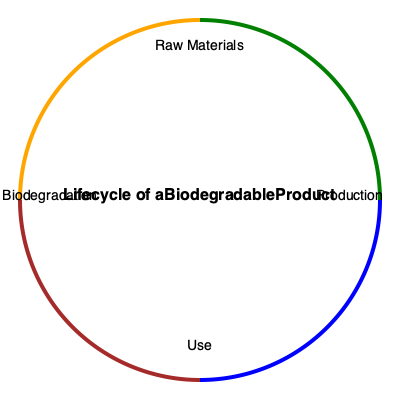In the lifecycle analysis of a biodegradable product, which stage typically has the highest carbon footprint, and what strategies can be implemented to reduce its environmental impact? To answer this question, let's analyze each stage of the lifecycle:

1. Raw Materials:
   - Generally has a lower carbon footprint compared to other stages
   - Involves extraction and processing of natural, renewable resources

2. Production:
   - Often has the highest carbon footprint due to:
     a) Energy-intensive manufacturing processes
     b) Use of machinery and equipment
     c) Transportation of materials to production facilities
   - Strategies to reduce impact:
     a) Implementing energy-efficient technologies
     b) Using renewable energy sources
     c) Optimizing production processes to minimize waste
     d) Adopting lean manufacturing principles

3. Use:
   - Usually has a lower impact for biodegradable products
   - Main concern is proper disposal and consumer education

4. Biodegradation:
   - Generally has a low carbon footprint
   - Relies on natural processes to break down the product

Given this analysis, the production stage typically has the highest carbon footprint in the lifecycle of a biodegradable product. To reduce its environmental impact, manufacturers can focus on energy efficiency, renewable energy sources, waste reduction, and process optimization.
Answer: Production stage; implement energy efficiency, use renewable energy, optimize processes, and reduce waste. 